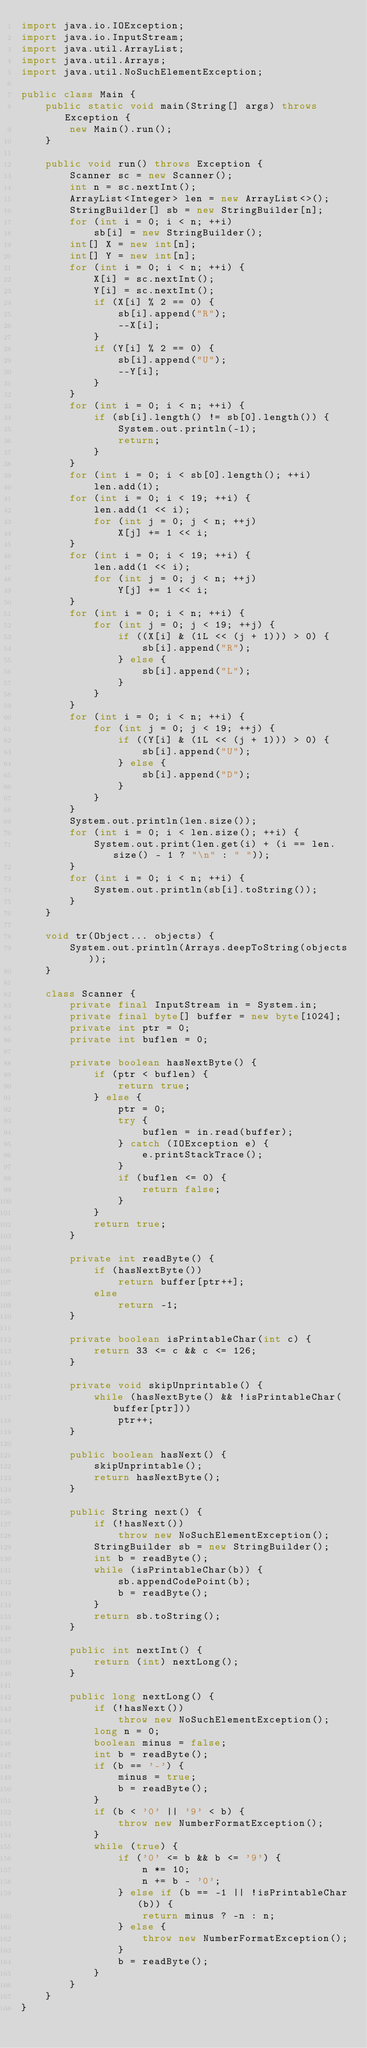<code> <loc_0><loc_0><loc_500><loc_500><_Java_>import java.io.IOException;
import java.io.InputStream;
import java.util.ArrayList;
import java.util.Arrays;
import java.util.NoSuchElementException;

public class Main {
	public static void main(String[] args) throws Exception {
		new Main().run();
	}

	public void run() throws Exception {
		Scanner sc = new Scanner();
		int n = sc.nextInt();
		ArrayList<Integer> len = new ArrayList<>();
		StringBuilder[] sb = new StringBuilder[n];
		for (int i = 0; i < n; ++i)
			sb[i] = new StringBuilder();
		int[] X = new int[n];
		int[] Y = new int[n];
		for (int i = 0; i < n; ++i) {
			X[i] = sc.nextInt();
			Y[i] = sc.nextInt();
			if (X[i] % 2 == 0) {
				sb[i].append("R");
				--X[i];
			}
			if (Y[i] % 2 == 0) {
				sb[i].append("U");
				--Y[i];
			}
		}
		for (int i = 0; i < n; ++i) {
			if (sb[i].length() != sb[0].length()) {
				System.out.println(-1);
				return;
			}
		}
		for (int i = 0; i < sb[0].length(); ++i)
			len.add(1);
		for (int i = 0; i < 19; ++i) {
			len.add(1 << i);
			for (int j = 0; j < n; ++j)
				X[j] += 1 << i;
		}
		for (int i = 0; i < 19; ++i) {
			len.add(1 << i);
			for (int j = 0; j < n; ++j)
				Y[j] += 1 << i;
		}
		for (int i = 0; i < n; ++i) {
			for (int j = 0; j < 19; ++j) {
				if ((X[i] & (1L << (j + 1))) > 0) {
					sb[i].append("R");
				} else {
					sb[i].append("L");
				}
			}
		}
		for (int i = 0; i < n; ++i) {
			for (int j = 0; j < 19; ++j) {
				if ((Y[i] & (1L << (j + 1))) > 0) {
					sb[i].append("U");
				} else {
					sb[i].append("D");
				}
			}
		}
		System.out.println(len.size());
		for (int i = 0; i < len.size(); ++i) {
			System.out.print(len.get(i) + (i == len.size() - 1 ? "\n" : " "));
		}
		for (int i = 0; i < n; ++i) {
			System.out.println(sb[i].toString());
		}
	}

	void tr(Object... objects) {
		System.out.println(Arrays.deepToString(objects));
	}

	class Scanner {
		private final InputStream in = System.in;
		private final byte[] buffer = new byte[1024];
		private int ptr = 0;
		private int buflen = 0;

		private boolean hasNextByte() {
			if (ptr < buflen) {
				return true;
			} else {
				ptr = 0;
				try {
					buflen = in.read(buffer);
				} catch (IOException e) {
					e.printStackTrace();
				}
				if (buflen <= 0) {
					return false;
				}
			}
			return true;
		}

		private int readByte() {
			if (hasNextByte())
				return buffer[ptr++];
			else
				return -1;
		}

		private boolean isPrintableChar(int c) {
			return 33 <= c && c <= 126;
		}

		private void skipUnprintable() {
			while (hasNextByte() && !isPrintableChar(buffer[ptr]))
				ptr++;
		}

		public boolean hasNext() {
			skipUnprintable();
			return hasNextByte();
		}

		public String next() {
			if (!hasNext())
				throw new NoSuchElementException();
			StringBuilder sb = new StringBuilder();
			int b = readByte();
			while (isPrintableChar(b)) {
				sb.appendCodePoint(b);
				b = readByte();
			}
			return sb.toString();
		}

		public int nextInt() {
			return (int) nextLong();
		}

		public long nextLong() {
			if (!hasNext())
				throw new NoSuchElementException();
			long n = 0;
			boolean minus = false;
			int b = readByte();
			if (b == '-') {
				minus = true;
				b = readByte();
			}
			if (b < '0' || '9' < b) {
				throw new NumberFormatException();
			}
			while (true) {
				if ('0' <= b && b <= '9') {
					n *= 10;
					n += b - '0';
				} else if (b == -1 || !isPrintableChar(b)) {
					return minus ? -n : n;
				} else {
					throw new NumberFormatException();
				}
				b = readByte();
			}
		}
	}
}</code> 